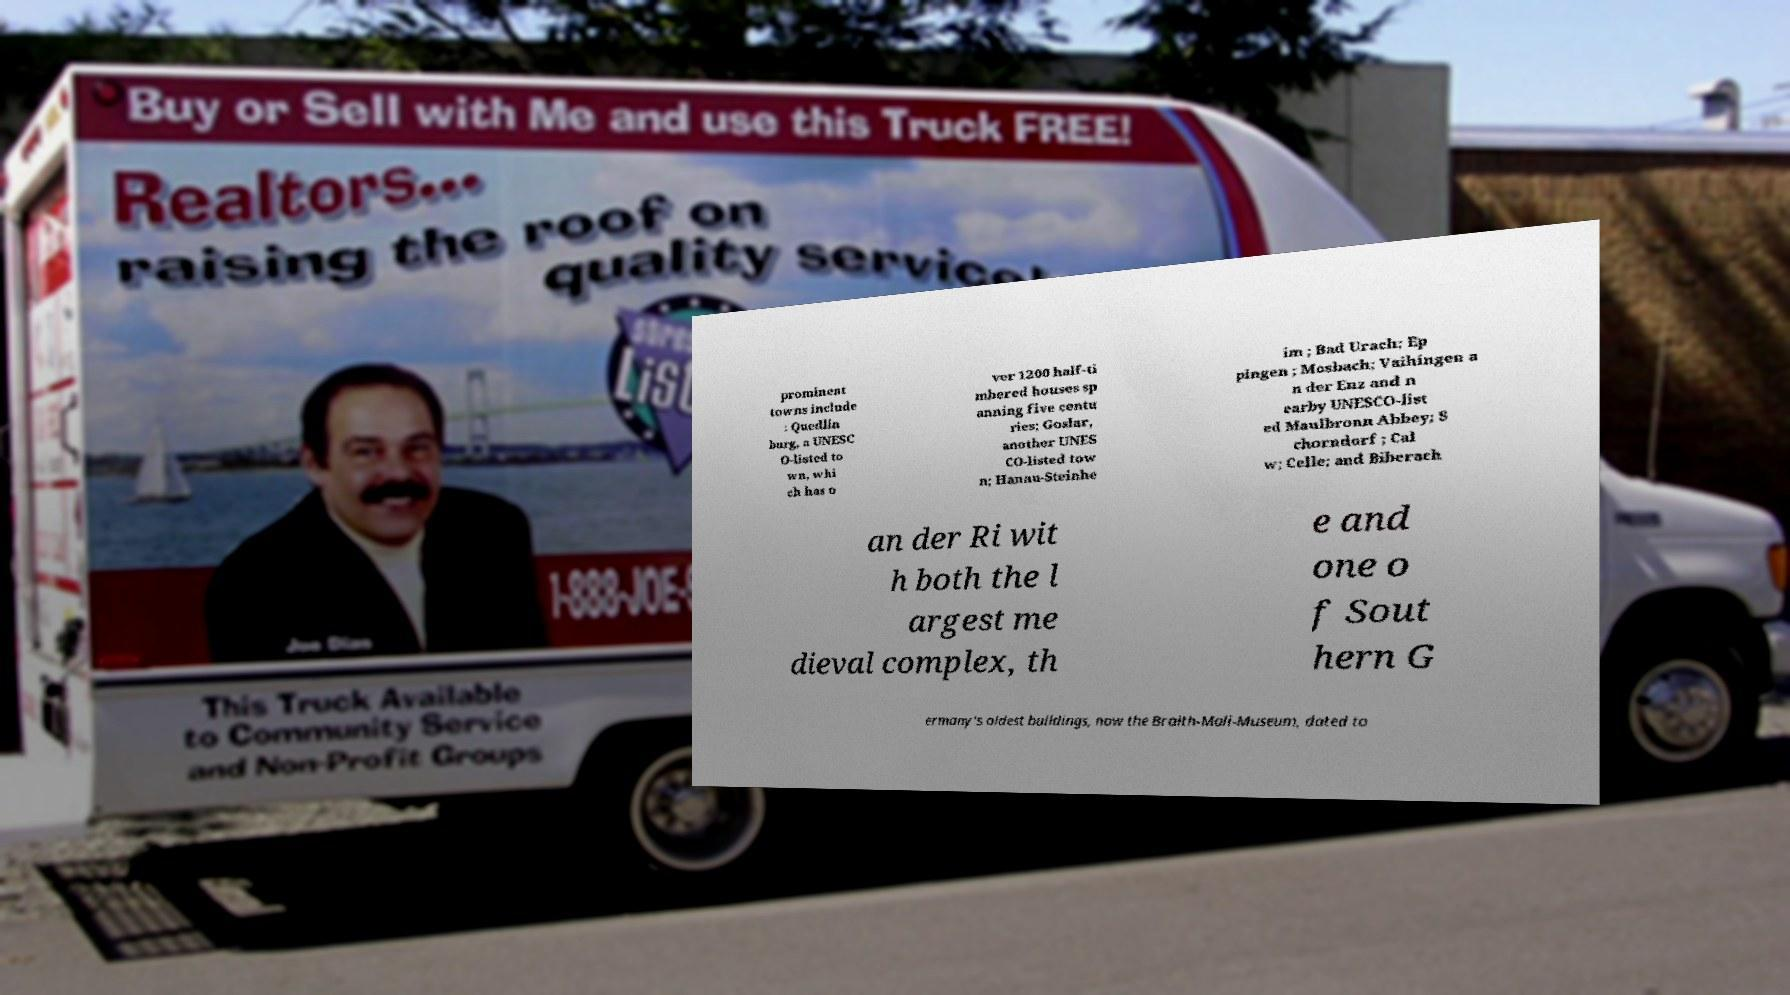There's text embedded in this image that I need extracted. Can you transcribe it verbatim? prominent towns include : Quedlin burg, a UNESC O-listed to wn, whi ch has o ver 1200 half-ti mbered houses sp anning five centu ries; Goslar, another UNES CO-listed tow n; Hanau-Steinhe im ; Bad Urach; Ep pingen ; Mosbach; Vaihingen a n der Enz and n earby UNESCO-list ed Maulbronn Abbey; S chorndorf ; Cal w; Celle; and Biberach an der Ri wit h both the l argest me dieval complex, th e and one o f Sout hern G ermany's oldest buildings, now the Braith-Mali-Museum, dated to 